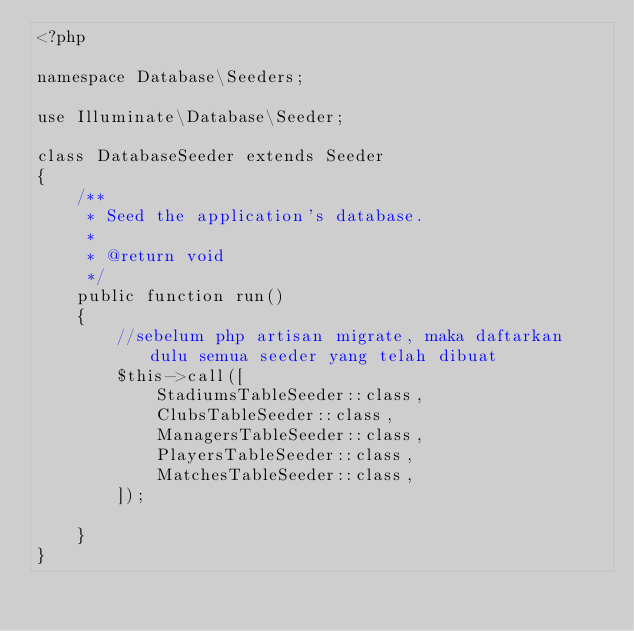<code> <loc_0><loc_0><loc_500><loc_500><_PHP_><?php

namespace Database\Seeders;

use Illuminate\Database\Seeder;

class DatabaseSeeder extends Seeder
{
    /**
     * Seed the application's database.
     *
     * @return void
     */
    public function run()
    {
        //sebelum php artisan migrate, maka daftarkan dulu semua seeder yang telah dibuat
        $this->call([
            StadiumsTableSeeder::class,
            ClubsTableSeeder::class,
            ManagersTableSeeder::class,
            PlayersTableSeeder::class,
            MatchesTableSeeder::class,
        ]);

    }
}
</code> 